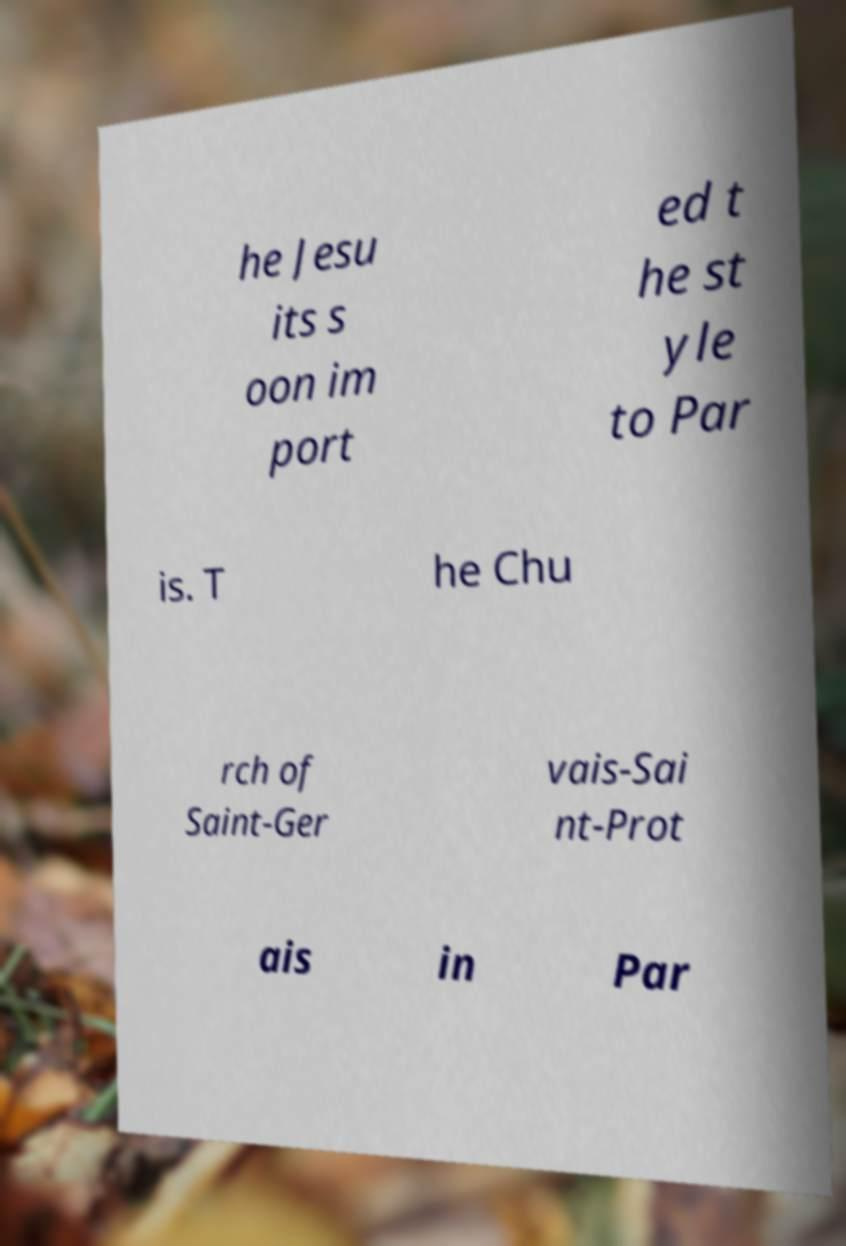For documentation purposes, I need the text within this image transcribed. Could you provide that? he Jesu its s oon im port ed t he st yle to Par is. T he Chu rch of Saint-Ger vais-Sai nt-Prot ais in Par 